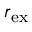<formula> <loc_0><loc_0><loc_500><loc_500>r _ { e x }</formula> 